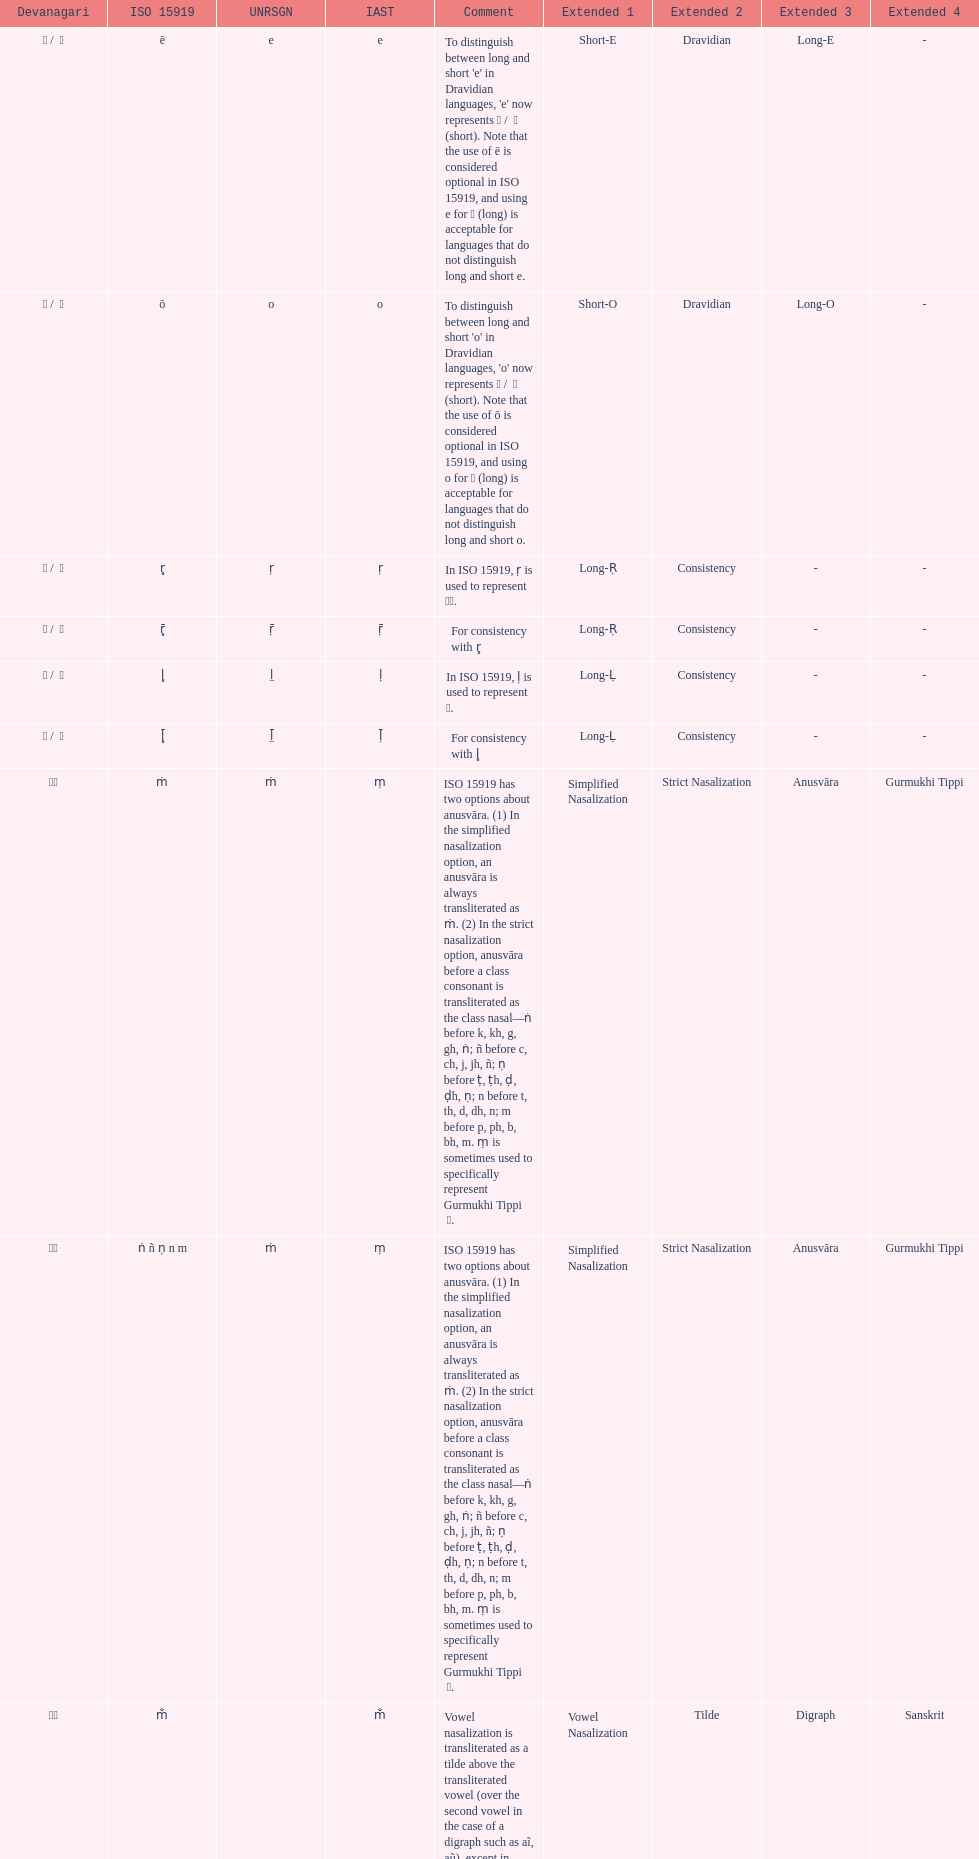What is the total number of translations? 8. 